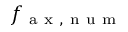Convert formula to latex. <formula><loc_0><loc_0><loc_500><loc_500>f _ { a x , n u m }</formula> 